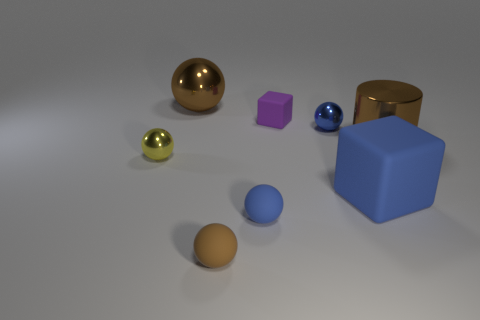There is a rubber block that is in front of the tiny yellow object; is its size the same as the brown shiny thing that is to the left of the small purple matte cube?
Your response must be concise. Yes. There is a brown object that is the same size as the shiny cylinder; what is its material?
Provide a succinct answer. Metal. There is a big thing that is behind the big blue matte cube and in front of the purple object; what material is it?
Keep it short and to the point. Metal. Is there a metal cylinder?
Your response must be concise. Yes. There is a cylinder; does it have the same color as the large matte object in front of the small cube?
Offer a very short reply. No. What material is the big object that is the same color as the metal cylinder?
Give a very brief answer. Metal. There is a large object that is to the left of the small ball behind the small yellow metal thing on the left side of the small brown ball; what shape is it?
Your answer should be very brief. Sphere. The tiny blue shiny object has what shape?
Your answer should be very brief. Sphere. There is a tiny metal sphere right of the tiny purple matte cube; what color is it?
Your answer should be compact. Blue. Do the cube that is behind the brown metallic cylinder and the tiny yellow metallic ball have the same size?
Your answer should be compact. Yes. 